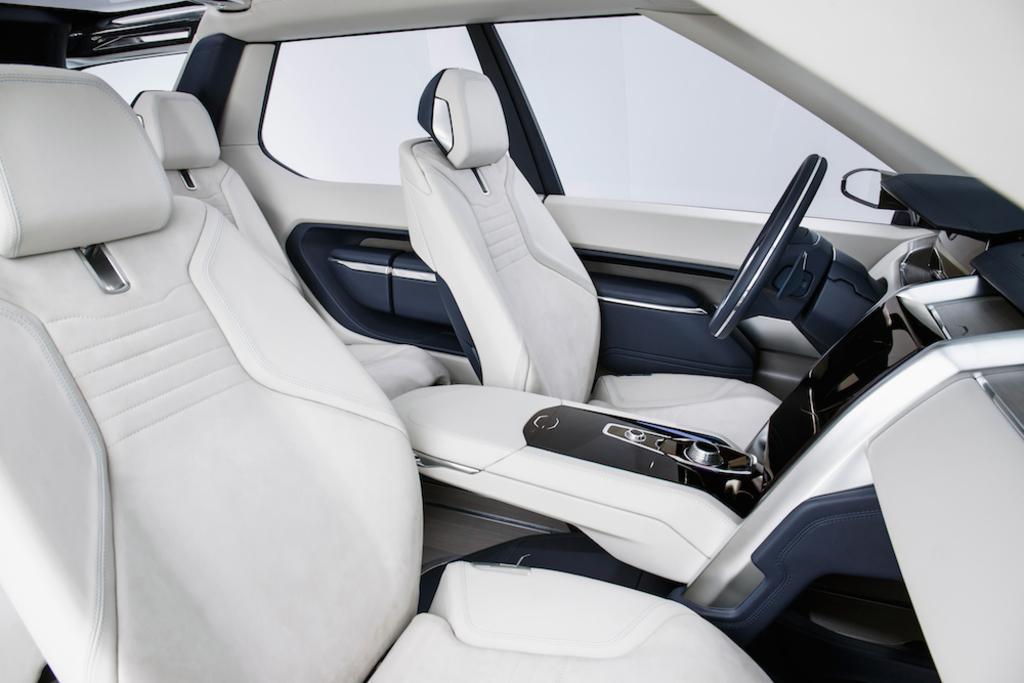Could you give a brief overview of what you see in this image? This picture describes about inside view of a car, in this we can find few seats, steering wheel and other things. 